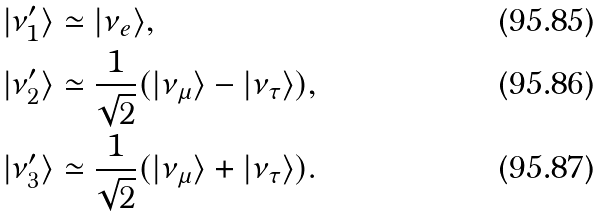Convert formula to latex. <formula><loc_0><loc_0><loc_500><loc_500>| \nu _ { 1 } ^ { \prime } \rangle & \simeq | \nu _ { e } \rangle , \\ | \nu _ { 2 } ^ { \prime } \rangle & \simeq \frac { 1 } { \sqrt { 2 } } ( | \nu _ { \mu } \rangle - | \nu _ { \tau } \rangle ) , \\ | \nu _ { 3 } ^ { \prime } \rangle & \simeq \frac { 1 } { \sqrt { 2 } } ( | \nu _ { \mu } \rangle + | \nu _ { \tau } \rangle ) .</formula> 